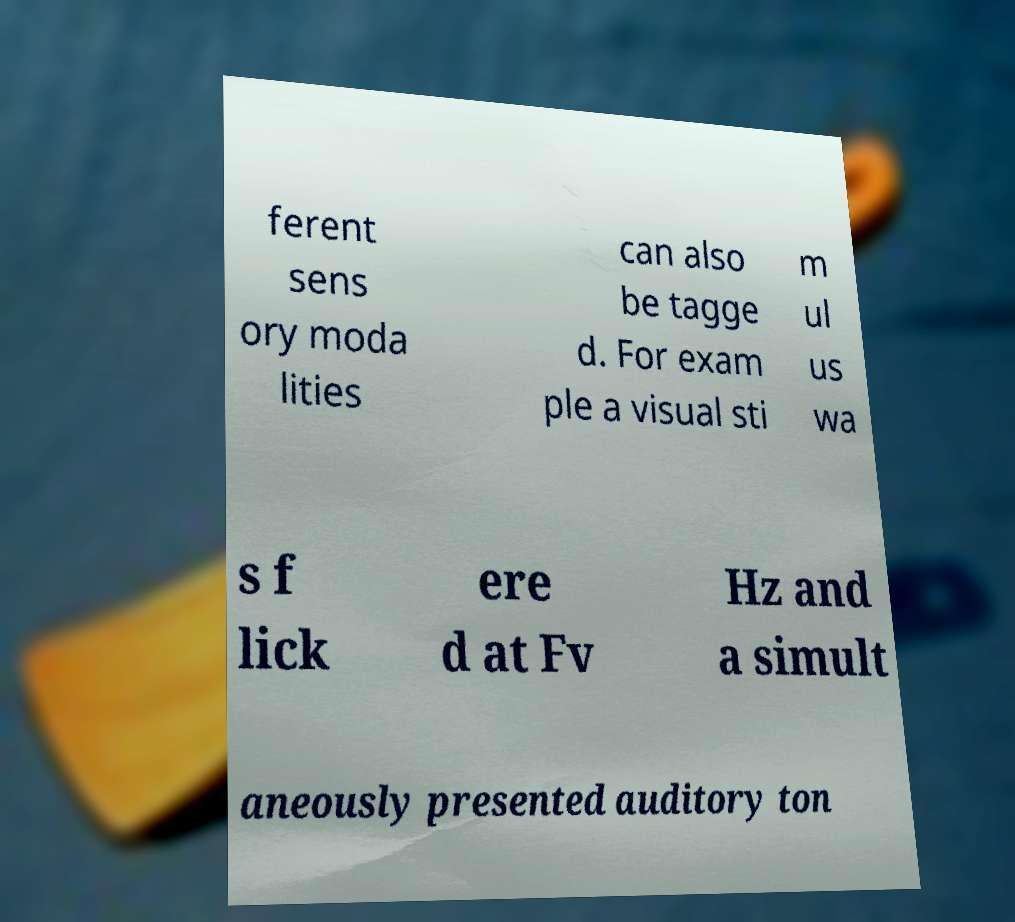Can you read and provide the text displayed in the image?This photo seems to have some interesting text. Can you extract and type it out for me? ferent sens ory moda lities can also be tagge d. For exam ple a visual sti m ul us wa s f lick ere d at Fv Hz and a simult aneously presented auditory ton 